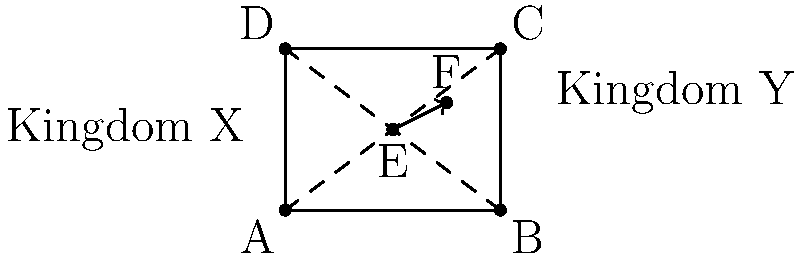In resolving a border dispute between Kingdom X and Kingdom Y, you propose translating the position of a crucial border marker (point E) by 1 unit east and 0.5 units north. If the original coordinates of point E were (2, 1.5), what are the new coordinates of the translated point F? Express your answer as an ordered pair (x, y). To solve this problem, we need to apply the principles of translation in transformational geometry. Here's a step-by-step explanation:

1. Identify the original coordinates:
   Point E is at (2, 1.5)

2. Determine the translation:
   - 1 unit east (in the positive x-direction)
   - 0.5 units north (in the positive y-direction)

3. Apply the translation:
   - New x-coordinate = Original x-coordinate + Translation in x
   - New y-coordinate = Original y-coordinate + Translation in y

4. Calculate the new coordinates:
   - New x-coordinate = 2 + 1 = 3
   - New y-coordinate = 1.5 + 0.5 = 2

5. Express the result as an ordered pair:
   The new coordinates of point F are (3, 2)

This translation effectively moves the border marker to a new position that may help resolve the territorial dispute between Kingdom X and Kingdom Y.
Answer: (3, 2) 